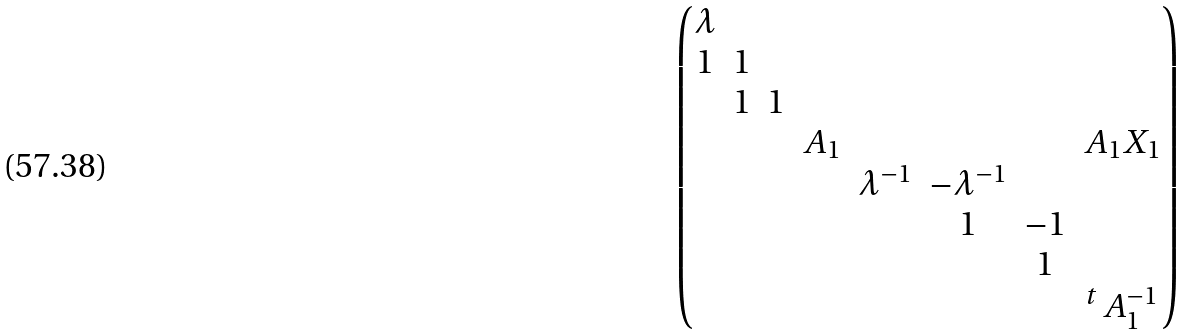Convert formula to latex. <formula><loc_0><loc_0><loc_500><loc_500>\begin{pmatrix} \lambda \\ 1 & 1 \\ & 1 & 1 \\ & & & A _ { 1 } & & & & A _ { 1 } X _ { 1 } \\ & & & & \lambda ^ { - 1 } & - \lambda ^ { - 1 } \\ & & & & & 1 & - 1 \\ & & & & & & 1 \\ & & & & & & & ^ { t } \, A _ { 1 } ^ { - 1 } \end{pmatrix}</formula> 